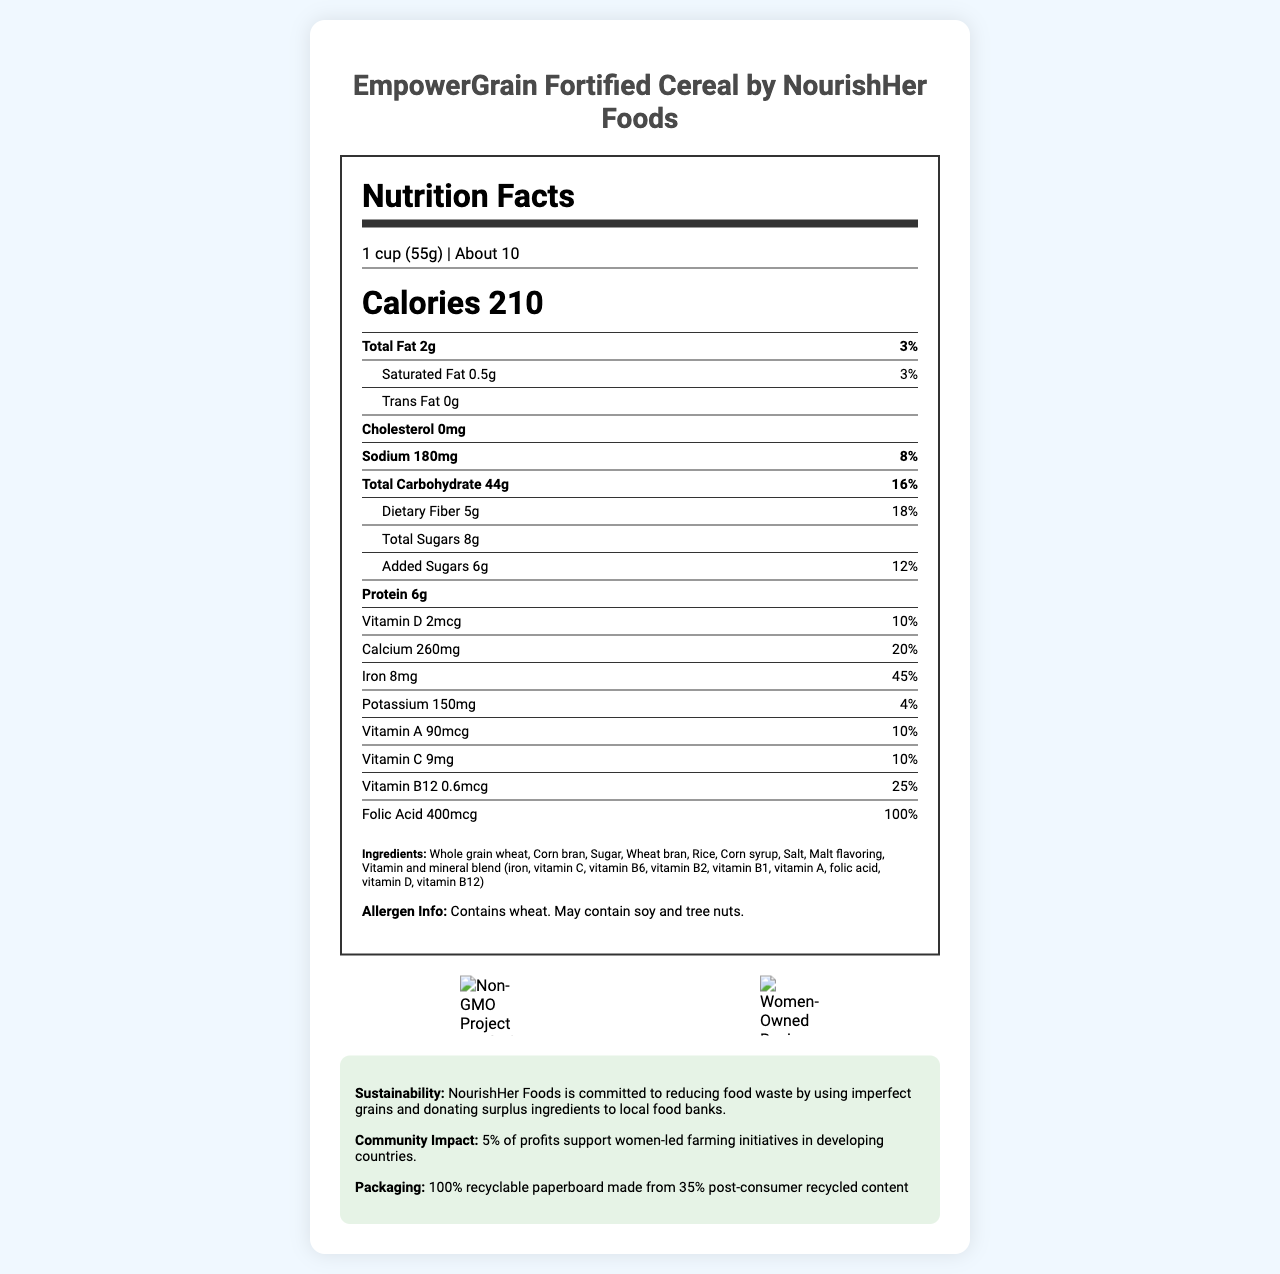What is the product name of the cereal? The product name is displayed as a title at the top of the document.
Answer: EmpowerGrain Fortified Cereal Which company produces EmpowerGrain Fortified Cereal? The company name is mentioned alongside the product name in the title.
Answer: NourishHer Foods What is the serving size of the cereal? The serving size is listed below the "Nutrition Facts" heading.
Answer: 1 cup (55g) What is the daily value percentage of dietary fiber? The daily value percentage for dietary fiber is listed next to its amount under the "Total Carbohydrate" section.
Answer: 18% How much added sugars does the cereal contain? The amount of added sugars is listed under the "Total Sugars" section.
Answer: 6g What is the amount of iron present in the cereal? A. 4mg B. 8mg C. 12mg D. 16mg The amount of iron is listed along with its daily value percentage under the vitamin and mineral section.
Answer: B. 8mg Which of the following certifications does NOT appear on the document? A. Non-GMO Project Verified B. Women-Owned Business Certified C. Fair Trade Certified The document only shows "Non-GMO Project Verified" and "Women-Owned Business Certified" as certifications.
Answer: C. Fair Trade Certified Does the cereal contain any allergens? The document states, "Allergen Info: Contains wheat. May contain soy and tree nuts."
Answer: Yes Does NourishHer Foods make any commitments towards reducing food waste or community support? The sustainability statement mentions using imperfect grains and donating surplus ingredients, and the community impact statement mentions supporting women-led farming initiatives.
Answer: Yes Summarize the key features and commitments of the EmpowerGrain Fortified Cereal from NourishHer Foods. The document highlights nutritional content, serving size, allergen information, certifications, and the company’s commitments to sustainability and community impact.
Answer: EmpowerGrain Fortified Cereal by NourishHer Foods is a 1 cup (55g) serving size cereal with 210 calories per serving, containing various vitamins and minerals, and fortified with 5g dietary fiber. It is Non-GMO Project Verified and Women-Owned Business Certified, with a commitment to reducing food waste by using imperfect grains and donating surplus ingredients. Additionally, it supports women-led farming initiatives in developing countries. The packaging is 100% recyclable. How does the company aim to support local communities? The sustainability statement mentions donating surplus ingredients to local food banks as part of their commitment to supporting local communities.
Answer: By donating surplus ingredients to local food banks What vitamins does the EmpowerGrain Fortified Cereal contain? These vitamins are listed under the vitamin and mineral section in the nutrition facts.
Answer: Vitamin D, Calcium, Iron, Potassium, Vitamin A, Vitamin C, Vitamin B12, Folic Acid How many servings are in a container of EmpowerGrain Fortified Cereal? The servings per container are listed under the serving size information.
Answer: About 10 What is the percentage of daily value for Vitamin B12? This percentage is shown under the vitamin and mineral section for Vitamin B12.
Answer: 25% What is the primary ingredient of the cereal? The ingredients list starts with whole grain wheat, indicating it's the primary ingredient.
Answer: Whole grain wheat What material is used for the packaging of the cereal? The packaging section mentions this specific detail.
Answer: 100% recyclable paperboard made from 35% post-consumer recycled content Does the cereal contain any cholesterol? The nutrition facts section lists cholesterol as 0mg.
Answer: No How much sodium does one serving of the cereal contain? The sodium content is listed along with its daily value percentage.
Answer: 180mg What percentage of profits supports women-led farming initiatives? The community impact statement mentions that 5% of profits support this cause.
Answer: 5% What is the source of the vitamin and mineral blend in the ingredients list? This is explicitly listed in the ingredients section of the document.
Answer: Contains iron, vitamin C, vitamin B6, vitamin B2, vitamin B1, vitamin A, folic acid, vitamin D, vitamin B12 Is there information about the exact percentage of imperfect grains used in the product? The sustainability statement mentions using imperfect grains but does not specify the percentage.
Answer: Not enough information 